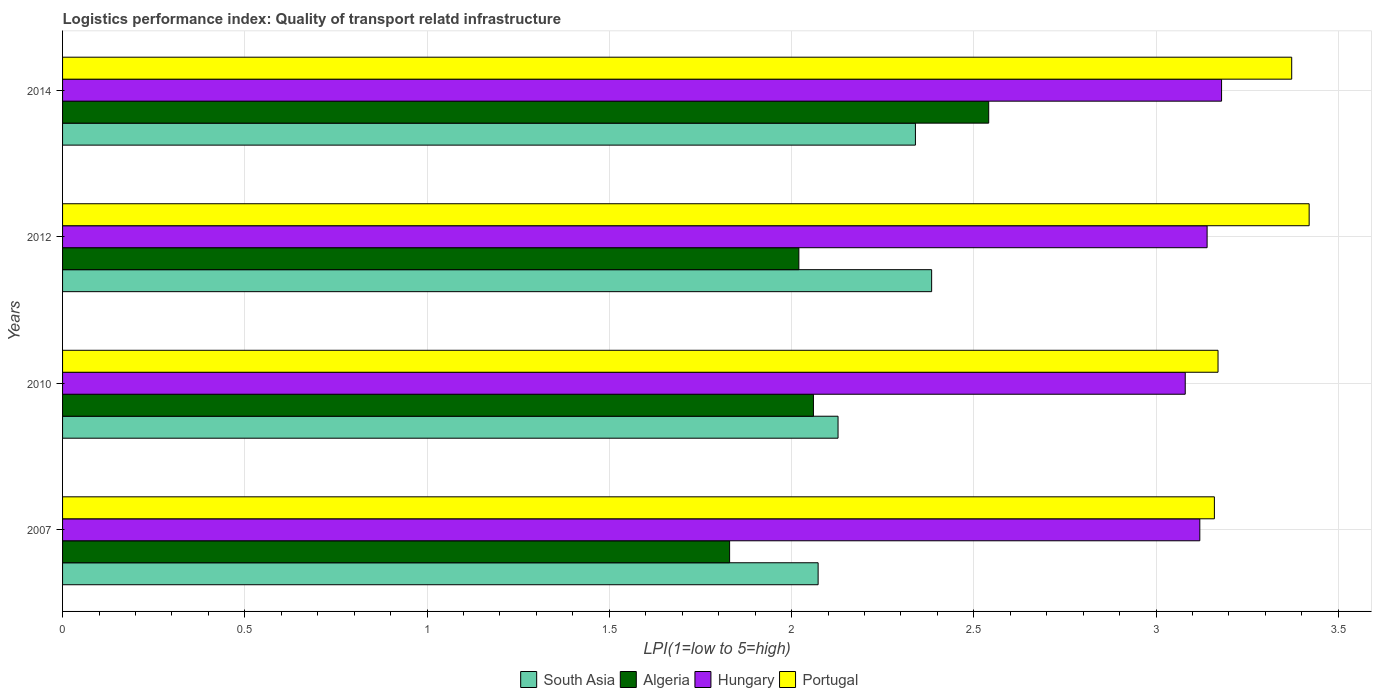How many different coloured bars are there?
Your response must be concise. 4. How many groups of bars are there?
Offer a terse response. 4. Are the number of bars per tick equal to the number of legend labels?
Provide a short and direct response. Yes. How many bars are there on the 1st tick from the top?
Ensure brevity in your answer.  4. How many bars are there on the 3rd tick from the bottom?
Give a very brief answer. 4. In how many cases, is the number of bars for a given year not equal to the number of legend labels?
Offer a terse response. 0. What is the logistics performance index in Algeria in 2014?
Your response must be concise. 2.54. Across all years, what is the maximum logistics performance index in Algeria?
Give a very brief answer. 2.54. Across all years, what is the minimum logistics performance index in Algeria?
Your answer should be compact. 1.83. In which year was the logistics performance index in Hungary minimum?
Your answer should be compact. 2010. What is the total logistics performance index in Portugal in the graph?
Provide a succinct answer. 13.12. What is the difference between the logistics performance index in Hungary in 2007 and that in 2012?
Make the answer very short. -0.02. What is the difference between the logistics performance index in Algeria in 2007 and the logistics performance index in South Asia in 2012?
Provide a succinct answer. -0.55. What is the average logistics performance index in Portugal per year?
Your answer should be compact. 3.28. In the year 2007, what is the difference between the logistics performance index in South Asia and logistics performance index in Hungary?
Provide a succinct answer. -1.05. In how many years, is the logistics performance index in Portugal greater than 1.8 ?
Keep it short and to the point. 4. What is the ratio of the logistics performance index in South Asia in 2007 to that in 2012?
Give a very brief answer. 0.87. What is the difference between the highest and the second highest logistics performance index in South Asia?
Offer a very short reply. 0.04. What is the difference between the highest and the lowest logistics performance index in South Asia?
Make the answer very short. 0.31. What does the 1st bar from the bottom in 2007 represents?
Your answer should be very brief. South Asia. Is it the case that in every year, the sum of the logistics performance index in South Asia and logistics performance index in Portugal is greater than the logistics performance index in Algeria?
Ensure brevity in your answer.  Yes. How many bars are there?
Provide a short and direct response. 16. How many years are there in the graph?
Offer a very short reply. 4. Does the graph contain grids?
Your response must be concise. Yes. How many legend labels are there?
Provide a succinct answer. 4. What is the title of the graph?
Provide a short and direct response. Logistics performance index: Quality of transport relatd infrastructure. What is the label or title of the X-axis?
Offer a very short reply. LPI(1=low to 5=high). What is the LPI(1=low to 5=high) in South Asia in 2007?
Offer a terse response. 2.07. What is the LPI(1=low to 5=high) of Algeria in 2007?
Make the answer very short. 1.83. What is the LPI(1=low to 5=high) of Hungary in 2007?
Give a very brief answer. 3.12. What is the LPI(1=low to 5=high) of Portugal in 2007?
Ensure brevity in your answer.  3.16. What is the LPI(1=low to 5=high) in South Asia in 2010?
Provide a succinct answer. 2.13. What is the LPI(1=low to 5=high) of Algeria in 2010?
Offer a terse response. 2.06. What is the LPI(1=low to 5=high) of Hungary in 2010?
Your answer should be very brief. 3.08. What is the LPI(1=low to 5=high) in Portugal in 2010?
Your answer should be very brief. 3.17. What is the LPI(1=low to 5=high) of South Asia in 2012?
Your answer should be very brief. 2.38. What is the LPI(1=low to 5=high) in Algeria in 2012?
Your answer should be compact. 2.02. What is the LPI(1=low to 5=high) in Hungary in 2012?
Your answer should be compact. 3.14. What is the LPI(1=low to 5=high) of Portugal in 2012?
Offer a terse response. 3.42. What is the LPI(1=low to 5=high) in South Asia in 2014?
Your response must be concise. 2.34. What is the LPI(1=low to 5=high) of Algeria in 2014?
Your answer should be compact. 2.54. What is the LPI(1=low to 5=high) of Hungary in 2014?
Your answer should be very brief. 3.18. What is the LPI(1=low to 5=high) of Portugal in 2014?
Your answer should be compact. 3.37. Across all years, what is the maximum LPI(1=low to 5=high) in South Asia?
Your answer should be compact. 2.38. Across all years, what is the maximum LPI(1=low to 5=high) of Algeria?
Offer a very short reply. 2.54. Across all years, what is the maximum LPI(1=low to 5=high) in Hungary?
Your answer should be compact. 3.18. Across all years, what is the maximum LPI(1=low to 5=high) in Portugal?
Offer a very short reply. 3.42. Across all years, what is the minimum LPI(1=low to 5=high) of South Asia?
Ensure brevity in your answer.  2.07. Across all years, what is the minimum LPI(1=low to 5=high) in Algeria?
Provide a short and direct response. 1.83. Across all years, what is the minimum LPI(1=low to 5=high) in Hungary?
Ensure brevity in your answer.  3.08. Across all years, what is the minimum LPI(1=low to 5=high) in Portugal?
Your answer should be compact. 3.16. What is the total LPI(1=low to 5=high) of South Asia in the graph?
Give a very brief answer. 8.92. What is the total LPI(1=low to 5=high) in Algeria in the graph?
Provide a short and direct response. 8.45. What is the total LPI(1=low to 5=high) of Hungary in the graph?
Make the answer very short. 12.52. What is the total LPI(1=low to 5=high) in Portugal in the graph?
Provide a succinct answer. 13.12. What is the difference between the LPI(1=low to 5=high) of South Asia in 2007 and that in 2010?
Your answer should be very brief. -0.05. What is the difference between the LPI(1=low to 5=high) in Algeria in 2007 and that in 2010?
Give a very brief answer. -0.23. What is the difference between the LPI(1=low to 5=high) of Portugal in 2007 and that in 2010?
Your response must be concise. -0.01. What is the difference between the LPI(1=low to 5=high) in South Asia in 2007 and that in 2012?
Keep it short and to the point. -0.31. What is the difference between the LPI(1=low to 5=high) of Algeria in 2007 and that in 2012?
Provide a succinct answer. -0.19. What is the difference between the LPI(1=low to 5=high) in Hungary in 2007 and that in 2012?
Offer a terse response. -0.02. What is the difference between the LPI(1=low to 5=high) in Portugal in 2007 and that in 2012?
Offer a terse response. -0.26. What is the difference between the LPI(1=low to 5=high) in South Asia in 2007 and that in 2014?
Make the answer very short. -0.27. What is the difference between the LPI(1=low to 5=high) in Algeria in 2007 and that in 2014?
Your answer should be very brief. -0.71. What is the difference between the LPI(1=low to 5=high) in Hungary in 2007 and that in 2014?
Keep it short and to the point. -0.06. What is the difference between the LPI(1=low to 5=high) in Portugal in 2007 and that in 2014?
Your answer should be compact. -0.21. What is the difference between the LPI(1=low to 5=high) of South Asia in 2010 and that in 2012?
Make the answer very short. -0.26. What is the difference between the LPI(1=low to 5=high) of Algeria in 2010 and that in 2012?
Give a very brief answer. 0.04. What is the difference between the LPI(1=low to 5=high) in Hungary in 2010 and that in 2012?
Provide a succinct answer. -0.06. What is the difference between the LPI(1=low to 5=high) in Portugal in 2010 and that in 2012?
Make the answer very short. -0.25. What is the difference between the LPI(1=low to 5=high) in South Asia in 2010 and that in 2014?
Ensure brevity in your answer.  -0.21. What is the difference between the LPI(1=low to 5=high) in Algeria in 2010 and that in 2014?
Your answer should be very brief. -0.48. What is the difference between the LPI(1=low to 5=high) of Hungary in 2010 and that in 2014?
Make the answer very short. -0.1. What is the difference between the LPI(1=low to 5=high) of Portugal in 2010 and that in 2014?
Your answer should be very brief. -0.2. What is the difference between the LPI(1=low to 5=high) in South Asia in 2012 and that in 2014?
Offer a very short reply. 0.04. What is the difference between the LPI(1=low to 5=high) in Algeria in 2012 and that in 2014?
Provide a short and direct response. -0.52. What is the difference between the LPI(1=low to 5=high) of Hungary in 2012 and that in 2014?
Provide a short and direct response. -0.04. What is the difference between the LPI(1=low to 5=high) of Portugal in 2012 and that in 2014?
Keep it short and to the point. 0.05. What is the difference between the LPI(1=low to 5=high) of South Asia in 2007 and the LPI(1=low to 5=high) of Algeria in 2010?
Provide a succinct answer. 0.01. What is the difference between the LPI(1=low to 5=high) of South Asia in 2007 and the LPI(1=low to 5=high) of Hungary in 2010?
Make the answer very short. -1.01. What is the difference between the LPI(1=low to 5=high) in South Asia in 2007 and the LPI(1=low to 5=high) in Portugal in 2010?
Make the answer very short. -1.1. What is the difference between the LPI(1=low to 5=high) of Algeria in 2007 and the LPI(1=low to 5=high) of Hungary in 2010?
Your answer should be compact. -1.25. What is the difference between the LPI(1=low to 5=high) of Algeria in 2007 and the LPI(1=low to 5=high) of Portugal in 2010?
Provide a short and direct response. -1.34. What is the difference between the LPI(1=low to 5=high) of South Asia in 2007 and the LPI(1=low to 5=high) of Algeria in 2012?
Offer a very short reply. 0.05. What is the difference between the LPI(1=low to 5=high) in South Asia in 2007 and the LPI(1=low to 5=high) in Hungary in 2012?
Offer a terse response. -1.07. What is the difference between the LPI(1=low to 5=high) in South Asia in 2007 and the LPI(1=low to 5=high) in Portugal in 2012?
Offer a terse response. -1.35. What is the difference between the LPI(1=low to 5=high) of Algeria in 2007 and the LPI(1=low to 5=high) of Hungary in 2012?
Ensure brevity in your answer.  -1.31. What is the difference between the LPI(1=low to 5=high) in Algeria in 2007 and the LPI(1=low to 5=high) in Portugal in 2012?
Keep it short and to the point. -1.59. What is the difference between the LPI(1=low to 5=high) in South Asia in 2007 and the LPI(1=low to 5=high) in Algeria in 2014?
Provide a short and direct response. -0.47. What is the difference between the LPI(1=low to 5=high) of South Asia in 2007 and the LPI(1=low to 5=high) of Hungary in 2014?
Ensure brevity in your answer.  -1.11. What is the difference between the LPI(1=low to 5=high) in South Asia in 2007 and the LPI(1=low to 5=high) in Portugal in 2014?
Keep it short and to the point. -1.3. What is the difference between the LPI(1=low to 5=high) in Algeria in 2007 and the LPI(1=low to 5=high) in Hungary in 2014?
Provide a succinct answer. -1.35. What is the difference between the LPI(1=low to 5=high) of Algeria in 2007 and the LPI(1=low to 5=high) of Portugal in 2014?
Offer a terse response. -1.54. What is the difference between the LPI(1=low to 5=high) in Hungary in 2007 and the LPI(1=low to 5=high) in Portugal in 2014?
Your answer should be compact. -0.25. What is the difference between the LPI(1=low to 5=high) in South Asia in 2010 and the LPI(1=low to 5=high) in Algeria in 2012?
Your answer should be very brief. 0.11. What is the difference between the LPI(1=low to 5=high) in South Asia in 2010 and the LPI(1=low to 5=high) in Hungary in 2012?
Provide a short and direct response. -1.01. What is the difference between the LPI(1=low to 5=high) in South Asia in 2010 and the LPI(1=low to 5=high) in Portugal in 2012?
Keep it short and to the point. -1.29. What is the difference between the LPI(1=low to 5=high) in Algeria in 2010 and the LPI(1=low to 5=high) in Hungary in 2012?
Keep it short and to the point. -1.08. What is the difference between the LPI(1=low to 5=high) in Algeria in 2010 and the LPI(1=low to 5=high) in Portugal in 2012?
Offer a terse response. -1.36. What is the difference between the LPI(1=low to 5=high) in Hungary in 2010 and the LPI(1=low to 5=high) in Portugal in 2012?
Keep it short and to the point. -0.34. What is the difference between the LPI(1=low to 5=high) of South Asia in 2010 and the LPI(1=low to 5=high) of Algeria in 2014?
Give a very brief answer. -0.41. What is the difference between the LPI(1=low to 5=high) of South Asia in 2010 and the LPI(1=low to 5=high) of Hungary in 2014?
Offer a terse response. -1.05. What is the difference between the LPI(1=low to 5=high) in South Asia in 2010 and the LPI(1=low to 5=high) in Portugal in 2014?
Offer a very short reply. -1.24. What is the difference between the LPI(1=low to 5=high) of Algeria in 2010 and the LPI(1=low to 5=high) of Hungary in 2014?
Give a very brief answer. -1.12. What is the difference between the LPI(1=low to 5=high) of Algeria in 2010 and the LPI(1=low to 5=high) of Portugal in 2014?
Your answer should be compact. -1.31. What is the difference between the LPI(1=low to 5=high) of Hungary in 2010 and the LPI(1=low to 5=high) of Portugal in 2014?
Your answer should be very brief. -0.29. What is the difference between the LPI(1=low to 5=high) in South Asia in 2012 and the LPI(1=low to 5=high) in Algeria in 2014?
Your response must be concise. -0.16. What is the difference between the LPI(1=low to 5=high) in South Asia in 2012 and the LPI(1=low to 5=high) in Hungary in 2014?
Keep it short and to the point. -0.8. What is the difference between the LPI(1=low to 5=high) of South Asia in 2012 and the LPI(1=low to 5=high) of Portugal in 2014?
Give a very brief answer. -0.99. What is the difference between the LPI(1=low to 5=high) of Algeria in 2012 and the LPI(1=low to 5=high) of Hungary in 2014?
Provide a succinct answer. -1.16. What is the difference between the LPI(1=low to 5=high) in Algeria in 2012 and the LPI(1=low to 5=high) in Portugal in 2014?
Provide a succinct answer. -1.35. What is the difference between the LPI(1=low to 5=high) in Hungary in 2012 and the LPI(1=low to 5=high) in Portugal in 2014?
Make the answer very short. -0.23. What is the average LPI(1=low to 5=high) in South Asia per year?
Your response must be concise. 2.23. What is the average LPI(1=low to 5=high) of Algeria per year?
Your answer should be very brief. 2.11. What is the average LPI(1=low to 5=high) in Hungary per year?
Offer a very short reply. 3.13. What is the average LPI(1=low to 5=high) of Portugal per year?
Offer a very short reply. 3.28. In the year 2007, what is the difference between the LPI(1=low to 5=high) of South Asia and LPI(1=low to 5=high) of Algeria?
Offer a very short reply. 0.24. In the year 2007, what is the difference between the LPI(1=low to 5=high) in South Asia and LPI(1=low to 5=high) in Hungary?
Provide a succinct answer. -1.05. In the year 2007, what is the difference between the LPI(1=low to 5=high) of South Asia and LPI(1=low to 5=high) of Portugal?
Provide a short and direct response. -1.09. In the year 2007, what is the difference between the LPI(1=low to 5=high) in Algeria and LPI(1=low to 5=high) in Hungary?
Your response must be concise. -1.29. In the year 2007, what is the difference between the LPI(1=low to 5=high) in Algeria and LPI(1=low to 5=high) in Portugal?
Give a very brief answer. -1.33. In the year 2007, what is the difference between the LPI(1=low to 5=high) in Hungary and LPI(1=low to 5=high) in Portugal?
Provide a short and direct response. -0.04. In the year 2010, what is the difference between the LPI(1=low to 5=high) in South Asia and LPI(1=low to 5=high) in Algeria?
Give a very brief answer. 0.07. In the year 2010, what is the difference between the LPI(1=low to 5=high) in South Asia and LPI(1=low to 5=high) in Hungary?
Offer a terse response. -0.95. In the year 2010, what is the difference between the LPI(1=low to 5=high) in South Asia and LPI(1=low to 5=high) in Portugal?
Your answer should be very brief. -1.04. In the year 2010, what is the difference between the LPI(1=low to 5=high) of Algeria and LPI(1=low to 5=high) of Hungary?
Offer a very short reply. -1.02. In the year 2010, what is the difference between the LPI(1=low to 5=high) in Algeria and LPI(1=low to 5=high) in Portugal?
Make the answer very short. -1.11. In the year 2010, what is the difference between the LPI(1=low to 5=high) of Hungary and LPI(1=low to 5=high) of Portugal?
Offer a terse response. -0.09. In the year 2012, what is the difference between the LPI(1=low to 5=high) in South Asia and LPI(1=low to 5=high) in Algeria?
Keep it short and to the point. 0.36. In the year 2012, what is the difference between the LPI(1=low to 5=high) in South Asia and LPI(1=low to 5=high) in Hungary?
Your response must be concise. -0.76. In the year 2012, what is the difference between the LPI(1=low to 5=high) in South Asia and LPI(1=low to 5=high) in Portugal?
Give a very brief answer. -1.04. In the year 2012, what is the difference between the LPI(1=low to 5=high) of Algeria and LPI(1=low to 5=high) of Hungary?
Your answer should be compact. -1.12. In the year 2012, what is the difference between the LPI(1=low to 5=high) of Hungary and LPI(1=low to 5=high) of Portugal?
Your answer should be compact. -0.28. In the year 2014, what is the difference between the LPI(1=low to 5=high) of South Asia and LPI(1=low to 5=high) of Algeria?
Ensure brevity in your answer.  -0.2. In the year 2014, what is the difference between the LPI(1=low to 5=high) in South Asia and LPI(1=low to 5=high) in Hungary?
Your answer should be compact. -0.84. In the year 2014, what is the difference between the LPI(1=low to 5=high) of South Asia and LPI(1=low to 5=high) of Portugal?
Keep it short and to the point. -1.03. In the year 2014, what is the difference between the LPI(1=low to 5=high) of Algeria and LPI(1=low to 5=high) of Hungary?
Ensure brevity in your answer.  -0.64. In the year 2014, what is the difference between the LPI(1=low to 5=high) in Algeria and LPI(1=low to 5=high) in Portugal?
Give a very brief answer. -0.83. In the year 2014, what is the difference between the LPI(1=low to 5=high) of Hungary and LPI(1=low to 5=high) of Portugal?
Provide a short and direct response. -0.19. What is the ratio of the LPI(1=low to 5=high) in South Asia in 2007 to that in 2010?
Your response must be concise. 0.97. What is the ratio of the LPI(1=low to 5=high) of Algeria in 2007 to that in 2010?
Your response must be concise. 0.89. What is the ratio of the LPI(1=low to 5=high) of Hungary in 2007 to that in 2010?
Make the answer very short. 1.01. What is the ratio of the LPI(1=low to 5=high) in South Asia in 2007 to that in 2012?
Provide a succinct answer. 0.87. What is the ratio of the LPI(1=low to 5=high) in Algeria in 2007 to that in 2012?
Offer a terse response. 0.91. What is the ratio of the LPI(1=low to 5=high) of Portugal in 2007 to that in 2012?
Provide a short and direct response. 0.92. What is the ratio of the LPI(1=low to 5=high) in South Asia in 2007 to that in 2014?
Give a very brief answer. 0.89. What is the ratio of the LPI(1=low to 5=high) of Algeria in 2007 to that in 2014?
Your answer should be very brief. 0.72. What is the ratio of the LPI(1=low to 5=high) of Hungary in 2007 to that in 2014?
Provide a succinct answer. 0.98. What is the ratio of the LPI(1=low to 5=high) of Portugal in 2007 to that in 2014?
Give a very brief answer. 0.94. What is the ratio of the LPI(1=low to 5=high) of South Asia in 2010 to that in 2012?
Your answer should be compact. 0.89. What is the ratio of the LPI(1=low to 5=high) in Algeria in 2010 to that in 2012?
Make the answer very short. 1.02. What is the ratio of the LPI(1=low to 5=high) of Hungary in 2010 to that in 2012?
Ensure brevity in your answer.  0.98. What is the ratio of the LPI(1=low to 5=high) in Portugal in 2010 to that in 2012?
Keep it short and to the point. 0.93. What is the ratio of the LPI(1=low to 5=high) in South Asia in 2010 to that in 2014?
Your answer should be compact. 0.91. What is the ratio of the LPI(1=low to 5=high) in Algeria in 2010 to that in 2014?
Make the answer very short. 0.81. What is the ratio of the LPI(1=low to 5=high) of Hungary in 2010 to that in 2014?
Make the answer very short. 0.97. What is the ratio of the LPI(1=low to 5=high) in Portugal in 2010 to that in 2014?
Give a very brief answer. 0.94. What is the ratio of the LPI(1=low to 5=high) in Algeria in 2012 to that in 2014?
Make the answer very short. 0.8. What is the ratio of the LPI(1=low to 5=high) in Hungary in 2012 to that in 2014?
Your answer should be very brief. 0.99. What is the ratio of the LPI(1=low to 5=high) of Portugal in 2012 to that in 2014?
Make the answer very short. 1.01. What is the difference between the highest and the second highest LPI(1=low to 5=high) in South Asia?
Make the answer very short. 0.04. What is the difference between the highest and the second highest LPI(1=low to 5=high) of Algeria?
Provide a succinct answer. 0.48. What is the difference between the highest and the second highest LPI(1=low to 5=high) in Hungary?
Make the answer very short. 0.04. What is the difference between the highest and the second highest LPI(1=low to 5=high) in Portugal?
Provide a succinct answer. 0.05. What is the difference between the highest and the lowest LPI(1=low to 5=high) in South Asia?
Your answer should be compact. 0.31. What is the difference between the highest and the lowest LPI(1=low to 5=high) of Algeria?
Offer a very short reply. 0.71. What is the difference between the highest and the lowest LPI(1=low to 5=high) of Hungary?
Provide a short and direct response. 0.1. What is the difference between the highest and the lowest LPI(1=low to 5=high) of Portugal?
Give a very brief answer. 0.26. 